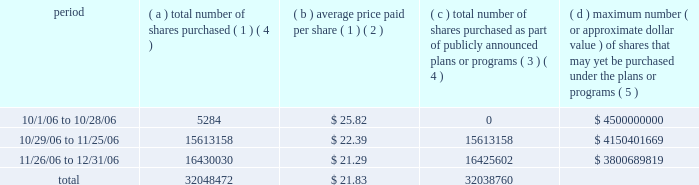Part ii item 5 : market for registrant's common equity , related stockholder matters and issuer purchases of equity securities motorola's common stock is listed on the new york and chicago stock exchanges .
The number of stockholders of record of motorola common stock on january 31 , 2007 was 75892 .
The remainder of the response to this item incorporates by reference note 16 , ""quarterly and other financial data ( unaudited ) '' of the notes to consolidated financial statements appearing under ""item 8 : financial statements and supplementary data'' .
The table provides information with respect to acquisitions by the company of shares of its common stock during the quarter ended december 31 , 2006 .
Issuer purchases of equity securities ( d ) maximum number ( c ) total number ( or approximate dollar of shares purchased value ) of shares that ( a ) total number ( b ) average price as part of publicly may yet be purchased of shares paid per announced plans under the plans or period purchased ( 1 ) ( 4 ) share ( 1 ) ( 2 ) or programs ( 3 ) ( 4 ) programs ( 5 ) .
( 1 ) in addition to purchases under the 2006 stock repurchase program ( as defined below ) , included in this column are transactions under the company's equity compensation plans involving the delivery to the company of 8445 shares of motorola common stock to satisfy tax withholding obligations in connection with the vesting of restricted stock granted to company employees and the surrender of 1267 shares of motorola common stock to pay the option exercise price in connection with the exercise of employee stock options .
( 2 ) average price paid per share of stock repurchased under the 2006 stock repurchase program is execution price , excluding commissions paid to brokers .
( 3 ) on may 18 , 2005 , the company announced that its board of directors authorized the company to repurchase up to $ 4 billion of its outstanding shares of common stock over a period of up to 36 months ending in may 2008 , subject to market conditions ( the ""2005 stock repurchase program'' ) .
On july 24 , 2006 , the company announced that it entered into an agreement to repurchase approximately $ 1.2 billion of its outstanding shares of common stock .
This repurchase , which was accomplished through an accelerated stock buyback ( ""asb'' ) agreement , together with all repurchases made prior to the date thereof , completed the repurchases authorized under the 2005 stock repurchase program .
Under the asb the company immediately paid $ 1.2 billion and received an initial 37.9 million shares in july followed by an additional 11.3 million shares in august .
In october , the company received an additional 1.3 million shares , as the final adjustment under the asb .
The total shares repurchased under the asb were 50.5 million .
( 4 ) the 1.3 million shares delivered under the asb that were delivered in october , but paid for in july , have not been reflected in october purchases .
( 5 ) the company also announced on july 24 , 2006 that its board of directors authorized the company to repurchase up to an additional $ 4.5 billion of its outstanding shares of common stock over a period of up to 36 months ending in june 2009 , subject to market conditions ( the ""2006 stock repurchase program'' ) .
%%transmsg*** transmitting job : c11830 pcn : 033000000 *** %%pcmsg| |00024|yes|no|02/28/2007 03:55|0|1|page is valid , no graphics -- color : n| .
In 2006 what was the percent of the total number of shares purchased as part of publicly announced plans or programs on or after 11/26/2006? 
Computations: (16425602 / 32038760)
Answer: 0.51268. 